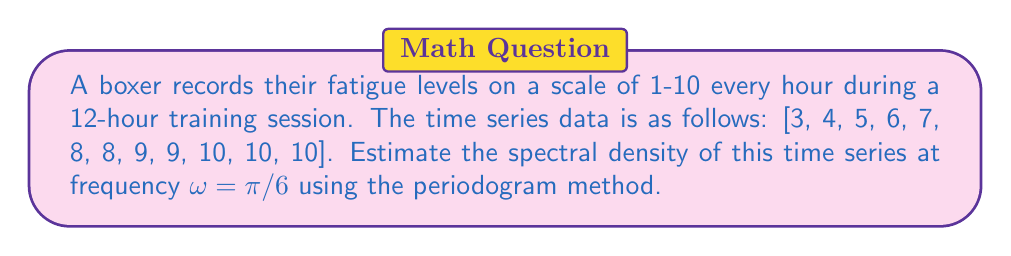Provide a solution to this math problem. To estimate the spectral density using the periodogram method:

1. Calculate the mean of the time series:
   $\bar{x} = \frac{1}{N}\sum_{t=1}^N x_t = \frac{89}{12} \approx 7.42$

2. Subtract the mean from each data point:
   $y_t = x_t - \bar{x}$

3. Calculate the discrete Fourier transform (DFT) at $\omega = \pi/6$:
   $$X(\omega) = \sum_{t=0}^{N-1} y_t e^{-i\omega t}$$
   
   For $\omega = \pi/6$:
   $$X(\pi/6) = \sum_{t=0}^{11} y_t e^{-i\pi t/6}$$

4. Calculate the periodogram:
   $$I(\omega) = \frac{1}{2\pi N}|X(\omega)|^2$$

5. Compute the real and imaginary parts of $X(\pi/6)$:
   $$\text{Re}[X(\pi/6)] \approx -10.37$$
   $$\text{Im}[X(\pi/6)] \approx -17.96$$

6. Calculate $|X(\pi/6)|^2$:
   $$|X(\pi/6)|^2 = (\text{Re}[X(\pi/6)])^2 + (\text{Im}[X(\pi/6)])^2 \approx 430.25$$

7. Estimate the spectral density:
   $$I(\pi/6) = \frac{1}{2\pi \cdot 12} \cdot 430.25 \approx 5.71$$
Answer: $5.71$ 